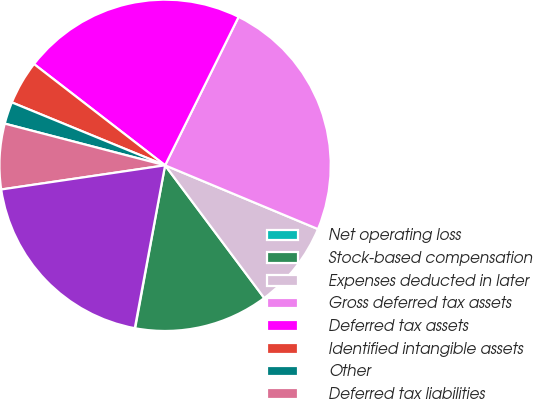Convert chart. <chart><loc_0><loc_0><loc_500><loc_500><pie_chart><fcel>Net operating loss<fcel>Stock-based compensation<fcel>Expenses deducted in later<fcel>Gross deferred tax assets<fcel>Deferred tax assets<fcel>Identified intangible assets<fcel>Other<fcel>Deferred tax liabilities<fcel>Net deferred tax assets<nl><fcel>0.04%<fcel>13.1%<fcel>8.5%<fcel>23.97%<fcel>21.85%<fcel>4.27%<fcel>2.15%<fcel>6.38%<fcel>19.74%<nl></chart> 